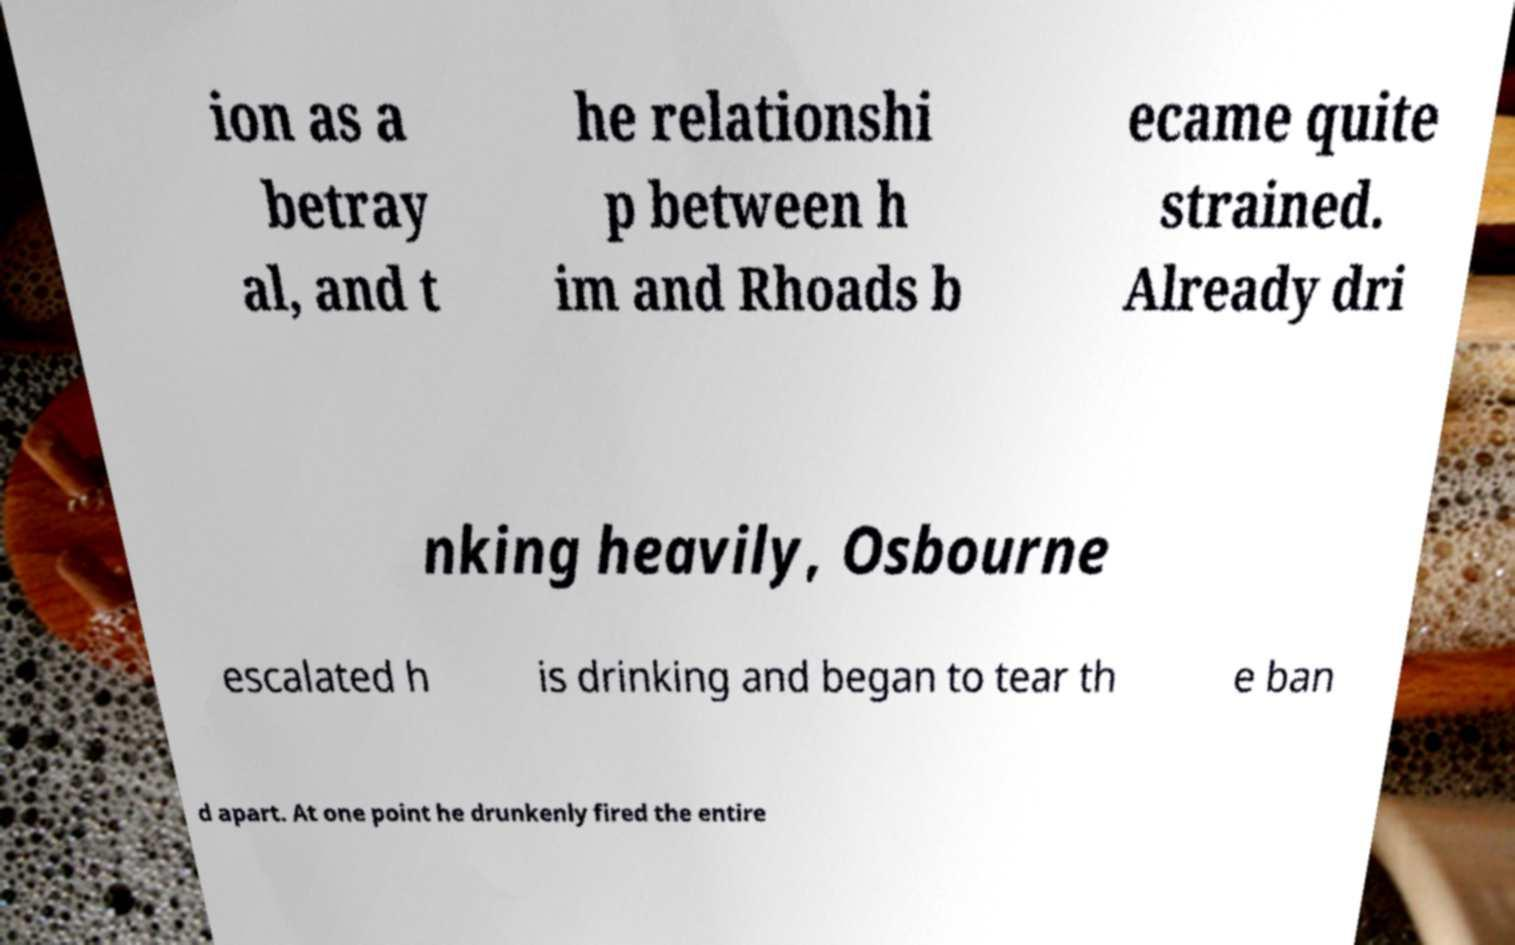Could you extract and type out the text from this image? ion as a betray al, and t he relationshi p between h im and Rhoads b ecame quite strained. Already dri nking heavily, Osbourne escalated h is drinking and began to tear th e ban d apart. At one point he drunkenly fired the entire 